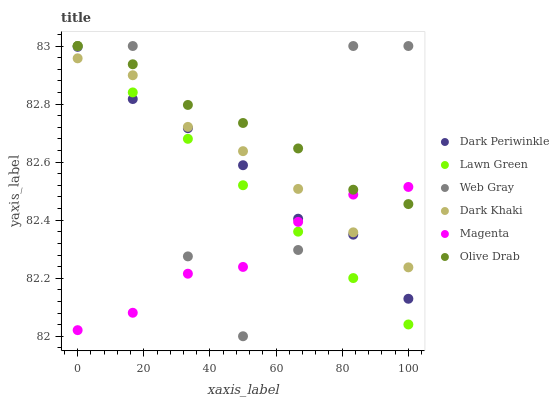Does Magenta have the minimum area under the curve?
Answer yes or no. Yes. Does Olive Drab have the maximum area under the curve?
Answer yes or no. Yes. Does Web Gray have the minimum area under the curve?
Answer yes or no. No. Does Web Gray have the maximum area under the curve?
Answer yes or no. No. Is Lawn Green the smoothest?
Answer yes or no. Yes. Is Web Gray the roughest?
Answer yes or no. Yes. Is Dark Khaki the smoothest?
Answer yes or no. No. Is Dark Khaki the roughest?
Answer yes or no. No. Does Web Gray have the lowest value?
Answer yes or no. Yes. Does Dark Khaki have the lowest value?
Answer yes or no. No. Does Olive Drab have the highest value?
Answer yes or no. Yes. Does Dark Khaki have the highest value?
Answer yes or no. No. Is Dark Periwinkle less than Olive Drab?
Answer yes or no. Yes. Is Olive Drab greater than Dark Periwinkle?
Answer yes or no. Yes. Does Web Gray intersect Magenta?
Answer yes or no. Yes. Is Web Gray less than Magenta?
Answer yes or no. No. Is Web Gray greater than Magenta?
Answer yes or no. No. Does Dark Periwinkle intersect Olive Drab?
Answer yes or no. No. 